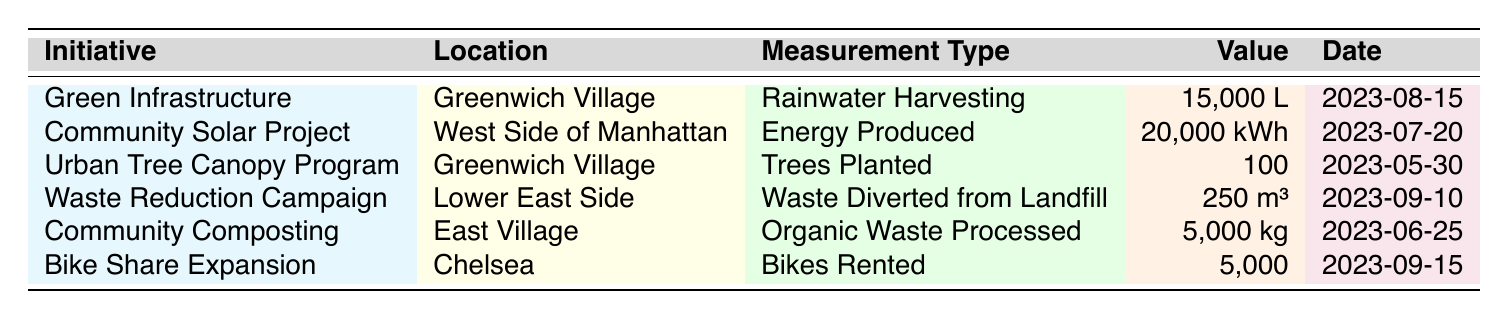What initiative captured 15,000 liters of rainwater? The table shows that the "Green Infrastructure Initiative" in Greenwich Village is responsible for capturing 15,000 liters of rainwater as indicated in the Measurement Type and Value columns.
Answer: Green Infrastructure Initiative How many trees were planted in the Urban Tree Canopy Program? According to the table, the "Urban Tree Canopy Program" planted 100 trees, which is listed under the Number of Trees column.
Answer: 100 What is the total volume of organic waste processed and waste diverted from landfill? The Community Composting Initiative processed 5,000 kilograms of organic waste while the Waste Reduction Campaign diverted 250 cubic meters of waste. To sum these, first convert 250 cubic meters to kilograms (considering approximate density) and then combine the values. Assuming 1 cubic meter of waste is about 1,000 kilograms, we have 250,000 kilograms + 5,000 kilograms = 255,000 kilograms in total.
Answer: 255,000 kilograms Did the Community Solar Project produce more energy than the volume of rainwater harvested by the Green Infrastructure Initiative? The Community Solar Project produced 20,000 kilowatt-hours of energy, while the Green Infrastructure Initiative captured 15,000 liters (which is not comparable directly to energy). However, since we are comparing different units, we can say "Yes," but the context of comparison is important.
Answer: Yes Which initiative generated more rentals, the Bike Share Expansion or the Urban Tree Canopy Program? The Bike Share Expansion had 5,000 bike rentals while the Urban Tree Canopy Program planted 100 trees. Since 5,000 is greater than 100, the answer is driven by a simple comparison of the two figures.
Answer: Bike Share Expansion What percentage increase in bikes rented does the Bike Share Expansion represent relative to the number of trees planted in the Urban Tree Canopy Program? The number of bikes rented is 5,000 and the number of trees planted is 100. The increase can be calculated as ((5,000 - 100) / 100) * 100 = 4,900%. This means there were significantly more bike rentals than trees planted.
Answer: 4,900% 